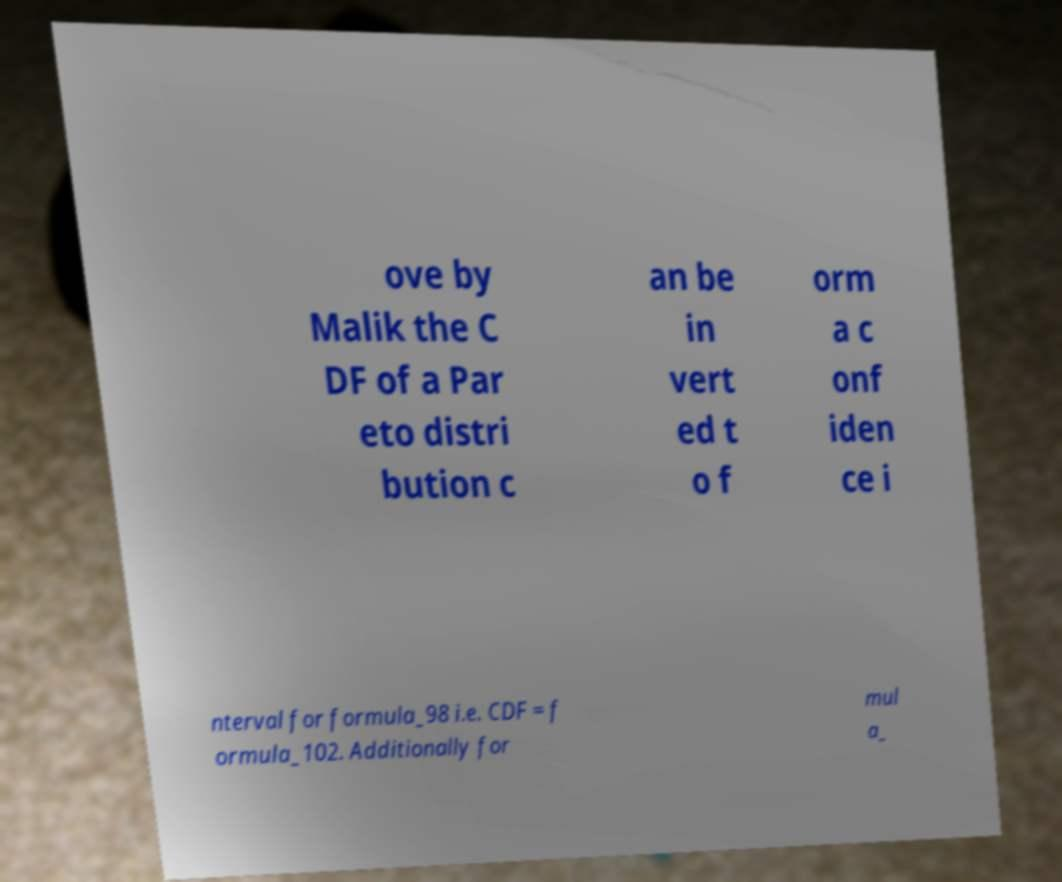Please identify and transcribe the text found in this image. ove by Malik the C DF of a Par eto distri bution c an be in vert ed t o f orm a c onf iden ce i nterval for formula_98 i.e. CDF = f ormula_102. Additionally for mul a_ 